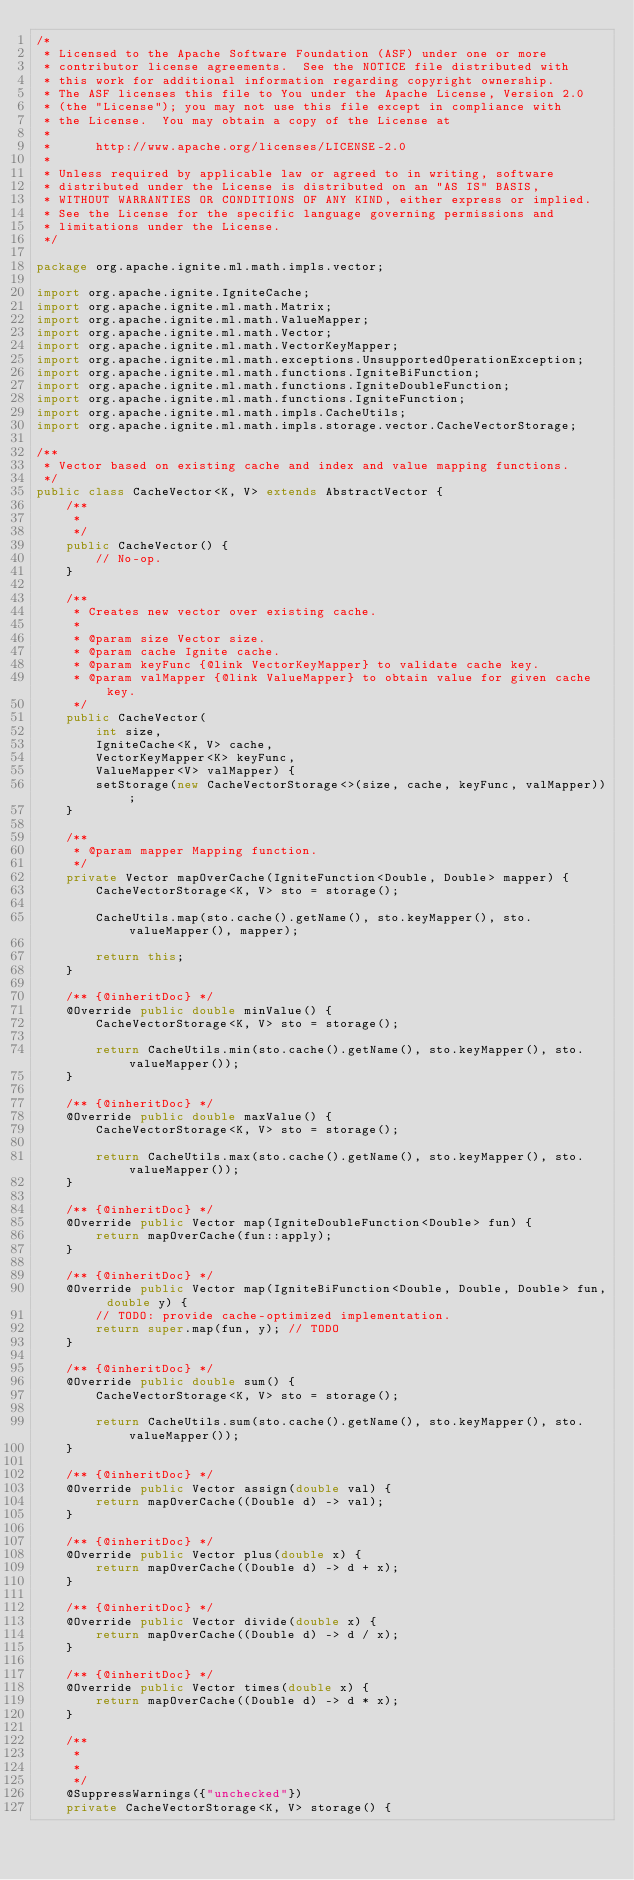<code> <loc_0><loc_0><loc_500><loc_500><_Java_>/*
 * Licensed to the Apache Software Foundation (ASF) under one or more
 * contributor license agreements.  See the NOTICE file distributed with
 * this work for additional information regarding copyright ownership.
 * The ASF licenses this file to You under the Apache License, Version 2.0
 * (the "License"); you may not use this file except in compliance with
 * the License.  You may obtain a copy of the License at
 *
 *      http://www.apache.org/licenses/LICENSE-2.0
 *
 * Unless required by applicable law or agreed to in writing, software
 * distributed under the License is distributed on an "AS IS" BASIS,
 * WITHOUT WARRANTIES OR CONDITIONS OF ANY KIND, either express or implied.
 * See the License for the specific language governing permissions and
 * limitations under the License.
 */

package org.apache.ignite.ml.math.impls.vector;

import org.apache.ignite.IgniteCache;
import org.apache.ignite.ml.math.Matrix;
import org.apache.ignite.ml.math.ValueMapper;
import org.apache.ignite.ml.math.Vector;
import org.apache.ignite.ml.math.VectorKeyMapper;
import org.apache.ignite.ml.math.exceptions.UnsupportedOperationException;
import org.apache.ignite.ml.math.functions.IgniteBiFunction;
import org.apache.ignite.ml.math.functions.IgniteDoubleFunction;
import org.apache.ignite.ml.math.functions.IgniteFunction;
import org.apache.ignite.ml.math.impls.CacheUtils;
import org.apache.ignite.ml.math.impls.storage.vector.CacheVectorStorage;

/**
 * Vector based on existing cache and index and value mapping functions.
 */
public class CacheVector<K, V> extends AbstractVector {
    /**
     *
     */
    public CacheVector() {
        // No-op.
    }

    /**
     * Creates new vector over existing cache.
     *
     * @param size Vector size.
     * @param cache Ignite cache.
     * @param keyFunc {@link VectorKeyMapper} to validate cache key.
     * @param valMapper {@link ValueMapper} to obtain value for given cache key.
     */
    public CacheVector(
        int size,
        IgniteCache<K, V> cache,
        VectorKeyMapper<K> keyFunc,
        ValueMapper<V> valMapper) {
        setStorage(new CacheVectorStorage<>(size, cache, keyFunc, valMapper));
    }

    /**
     * @param mapper Mapping function.
     */
    private Vector mapOverCache(IgniteFunction<Double, Double> mapper) {
        CacheVectorStorage<K, V> sto = storage();

        CacheUtils.map(sto.cache().getName(), sto.keyMapper(), sto.valueMapper(), mapper);

        return this;
    }

    /** {@inheritDoc} */
    @Override public double minValue() {
        CacheVectorStorage<K, V> sto = storage();

        return CacheUtils.min(sto.cache().getName(), sto.keyMapper(), sto.valueMapper());
    }

    /** {@inheritDoc} */
    @Override public double maxValue() {
        CacheVectorStorage<K, V> sto = storage();

        return CacheUtils.max(sto.cache().getName(), sto.keyMapper(), sto.valueMapper());
    }

    /** {@inheritDoc} */
    @Override public Vector map(IgniteDoubleFunction<Double> fun) {
        return mapOverCache(fun::apply);
    }

    /** {@inheritDoc} */
    @Override public Vector map(IgniteBiFunction<Double, Double, Double> fun, double y) {
        // TODO: provide cache-optimized implementation.
        return super.map(fun, y); // TODO
    }

    /** {@inheritDoc} */
    @Override public double sum() {
        CacheVectorStorage<K, V> sto = storage();

        return CacheUtils.sum(sto.cache().getName(), sto.keyMapper(), sto.valueMapper());
    }

    /** {@inheritDoc} */
    @Override public Vector assign(double val) {
        return mapOverCache((Double d) -> val);
    }

    /** {@inheritDoc} */
    @Override public Vector plus(double x) {
        return mapOverCache((Double d) -> d + x);
    }

    /** {@inheritDoc} */
    @Override public Vector divide(double x) {
        return mapOverCache((Double d) -> d / x);
    }

    /** {@inheritDoc} */
    @Override public Vector times(double x) {
        return mapOverCache((Double d) -> d * x);
    }

    /**
     *
     *
     */
    @SuppressWarnings({"unchecked"})
    private CacheVectorStorage<K, V> storage() {</code> 